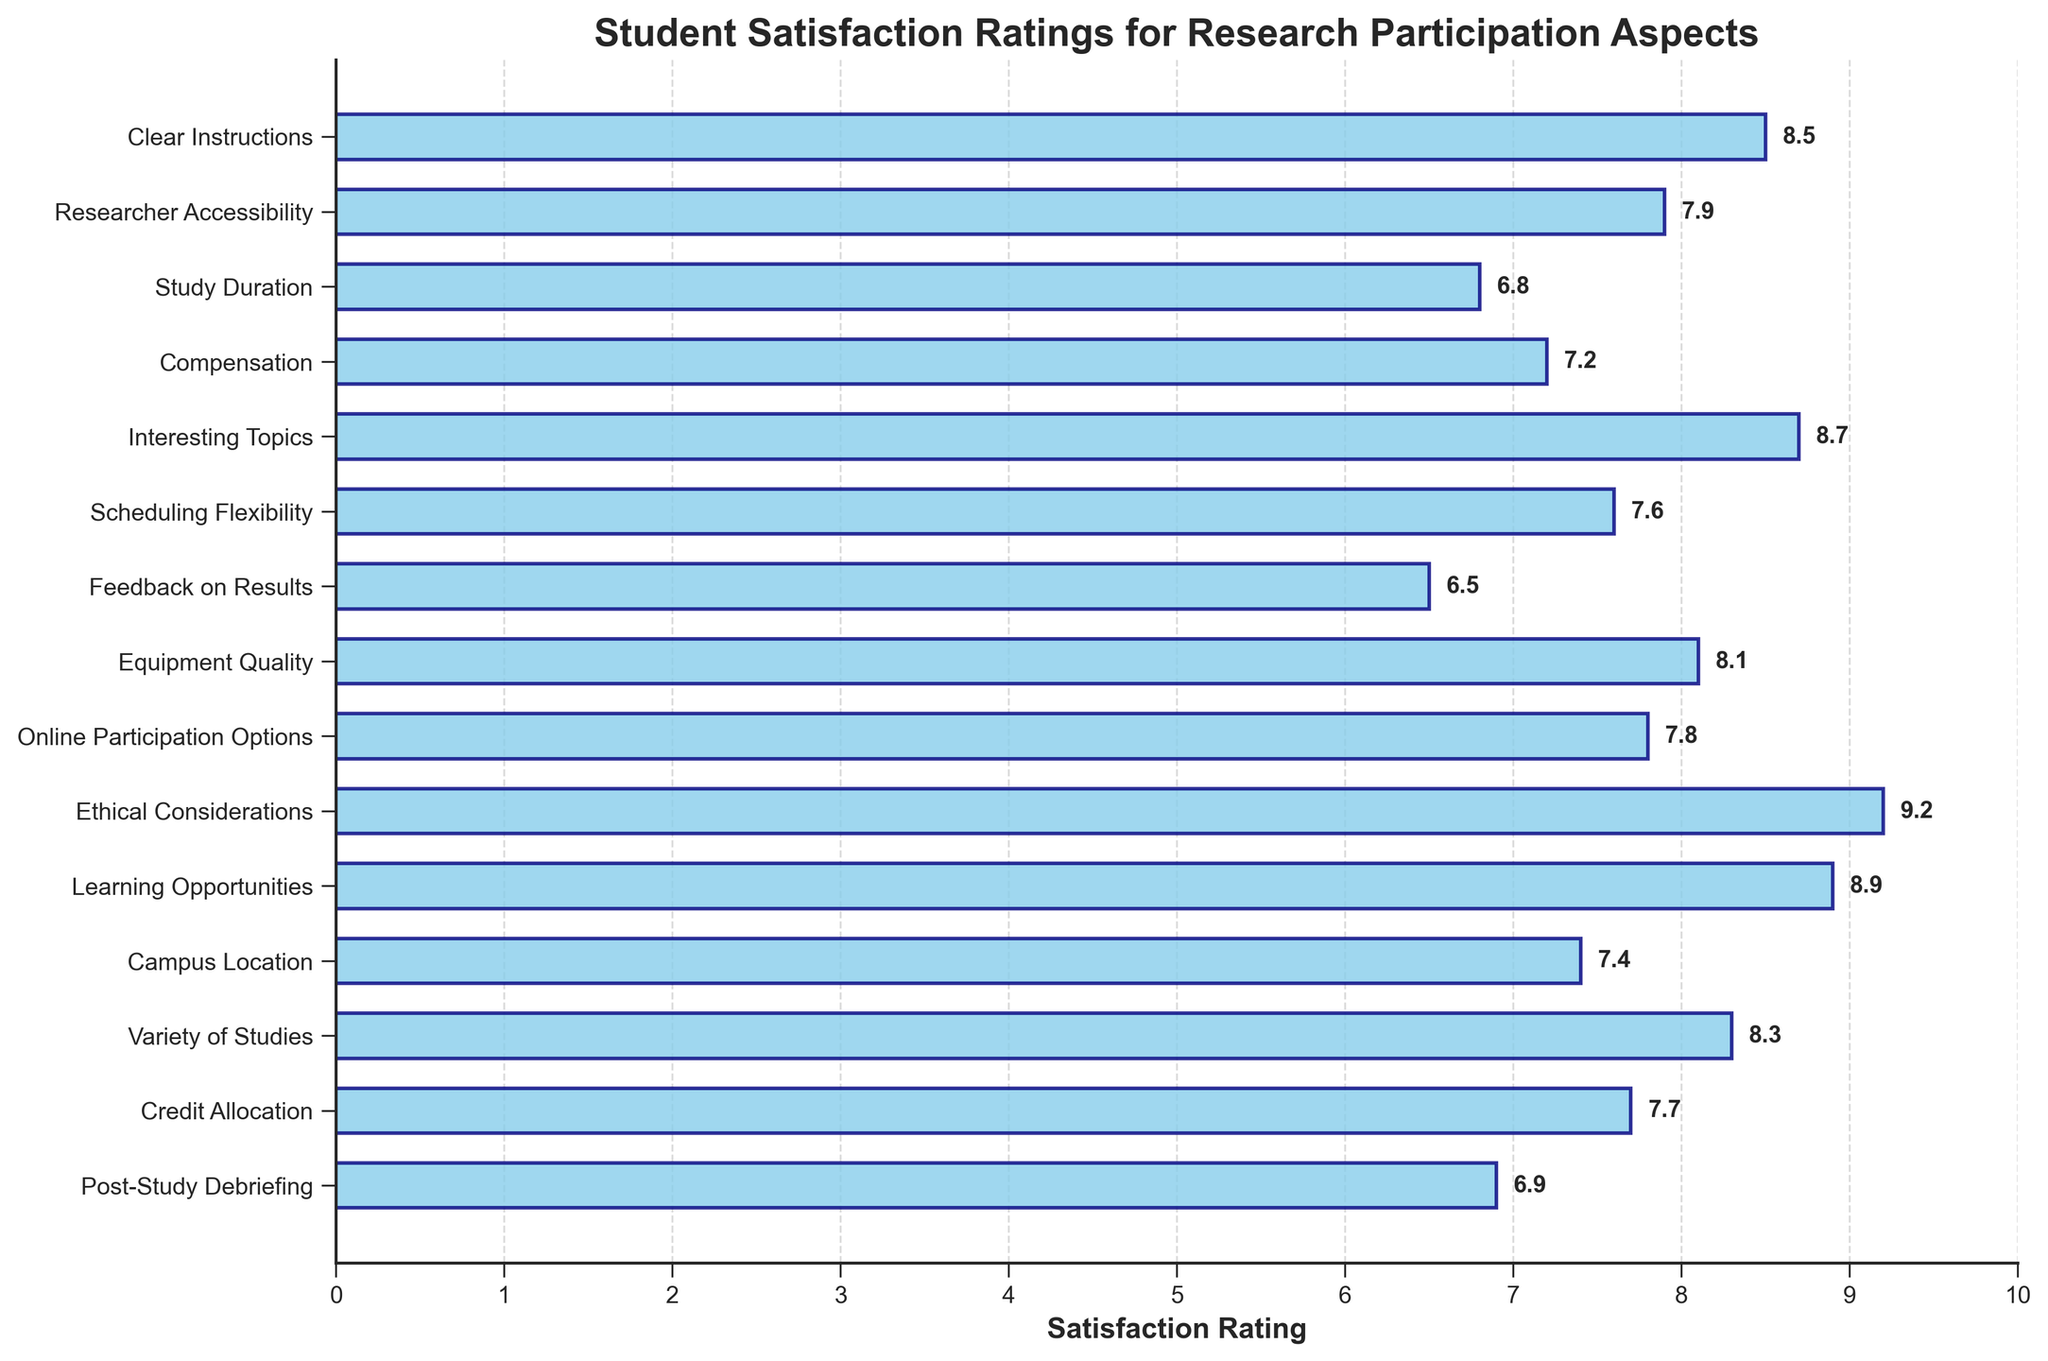What is the highest satisfaction rating aspect, and what is the rating? The highest satisfaction rating can be found by looking for the longest bar in the chart. The longest bar corresponds to the "Ethical Considerations" aspect, with a rating of 9.2.
Answer: Ethical Considerations, 9.2 Which aspect has the lowest satisfaction rating? The aspect with the shortest bar represents the lowest satisfaction rating. This corresponds to "Feedback on Results," with a rating of 6.5.
Answer: Feedback on Results What is the average satisfaction rating across all aspects? To find the average rating, sum all the ratings and then divide by the number of aspects. (8.5 + 7.9 + 6.8 + 7.2 + 8.7 + 7.6 + 6.5 + 8.1 + 7.8 + 9.2 + 8.9 + 7.4 + 8.3 + 7.7 + 6.9) / 15 = 118.5 / 15 = 7.9
Answer: 7.9 Which aspects have a satisfaction rating of 8 or higher? Aspects with bars reaching or exceeding the 8 mark on the x-axis are "Clear Instructions," "Interesting Topics," "Equipment Quality," "Ethical Considerations," "Learning Opportunities," and "Variety of Studies."
Answer: Clear Instructions, Interesting Topics, Equipment Quality, Ethical Considerations, Learning Opportunities, Variety of Studies How much higher is the satisfaction rating for "Ethical Considerations" compared to "Feedback on Results"? Subtract the satisfaction rating of "Feedback on Results" from that of "Ethical Considerations" (9.2 - 6.5 = 2.7).
Answer: 2.7 Which aspect has a similar satisfaction rating to "Credit Allocation"? The satisfaction rating for "Credit Allocation" is 7.7. The aspect with a similar rating is "Scheduling Flexibility," with a rating of 7.6.
Answer: Scheduling Flexibility Compare the satisfaction ratings for "Compensation" and "Equipment Quality." Which one is higher and by how much? The satisfaction rating for "Compensation" is 7.2, and for "Equipment Quality" it is 8.1. So, "Equipment Quality" is higher. The difference is (8.1 - 7.2 = 0.9).
Answer: Equipment Quality by 0.9 What is the combined satisfaction rating for "Campus Location" and "Online Participation Options"? Add the ratings for both aspects (7.4 + 7.8 = 15.2).
Answer: 15.2 Which aspect related to researcher interaction has a higher rating, "Researcher Accessibility" or "Post-Study Debriefing"? "Researcher Accessibility" has a rating of 7.9, whereas "Post-Study Debriefing" has a rating of 6.9. Therefore, "Researcher Accessibility" is higher.
Answer: Researcher Accessibility What is the difference between the ratings for "Study Duration" and "Scheduling Flexibility"? Subtract the rating of "Study Duration" from "Scheduling Flexibility" (7.6 - 6.8 = 0.8).
Answer: 0.8 